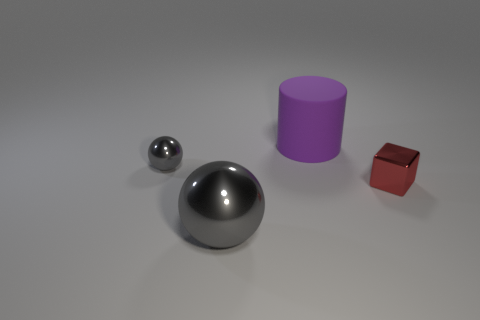Subtract 1 blocks. How many blocks are left? 0 Add 3 tiny spheres. How many objects exist? 7 Subtract all cylinders. How many objects are left? 3 Add 1 large rubber objects. How many large rubber objects exist? 2 Subtract 0 yellow spheres. How many objects are left? 4 Subtract all red cylinders. Subtract all brown spheres. How many cylinders are left? 1 Subtract all green blocks. How many red cylinders are left? 0 Subtract all big things. Subtract all purple things. How many objects are left? 1 Add 2 big shiny balls. How many big shiny balls are left? 3 